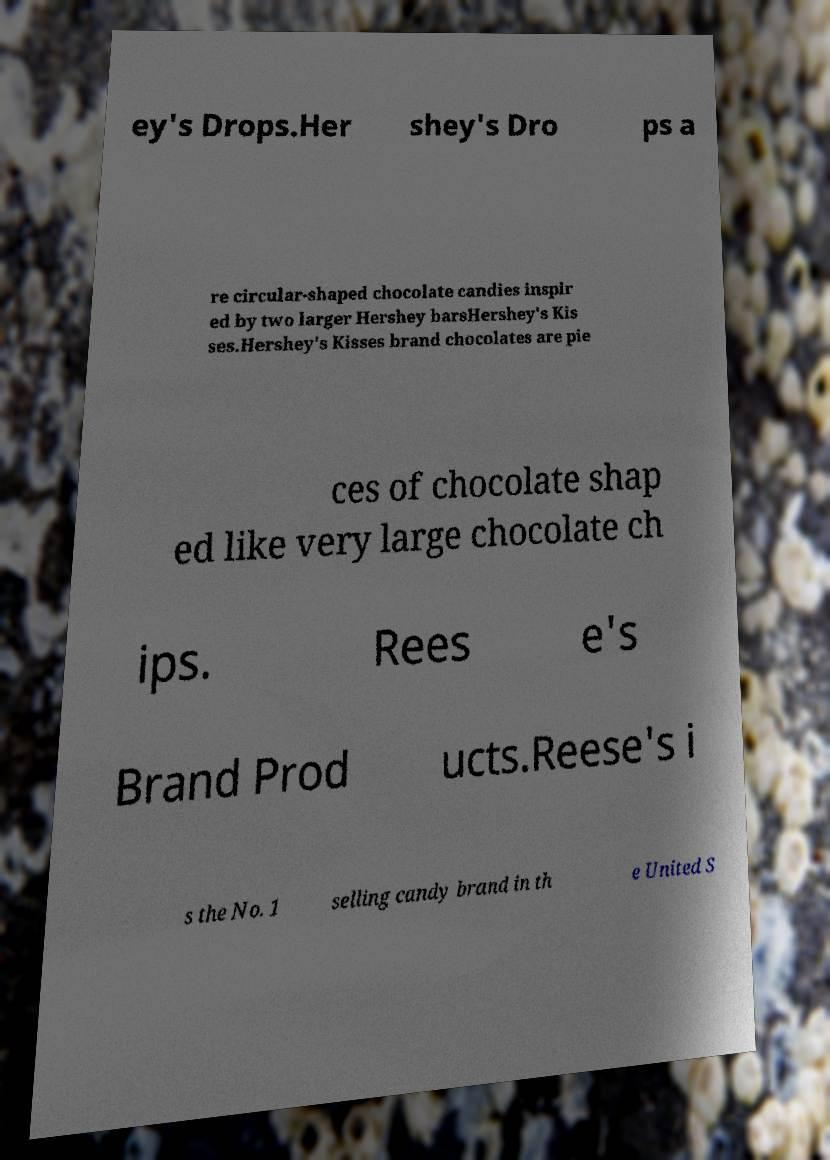Can you read and provide the text displayed in the image?This photo seems to have some interesting text. Can you extract and type it out for me? ey's Drops.Her shey's Dro ps a re circular-shaped chocolate candies inspir ed by two larger Hershey barsHershey's Kis ses.Hershey's Kisses brand chocolates are pie ces of chocolate shap ed like very large chocolate ch ips. Rees e's Brand Prod ucts.Reese's i s the No. 1 selling candy brand in th e United S 